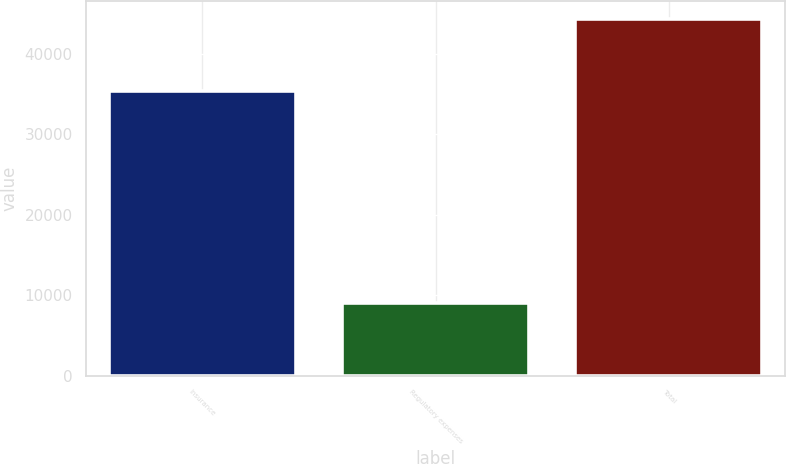<chart> <loc_0><loc_0><loc_500><loc_500><bar_chart><fcel>Insurance<fcel>Regulatory expenses<fcel>Total<nl><fcel>35406<fcel>8987<fcel>44393<nl></chart> 